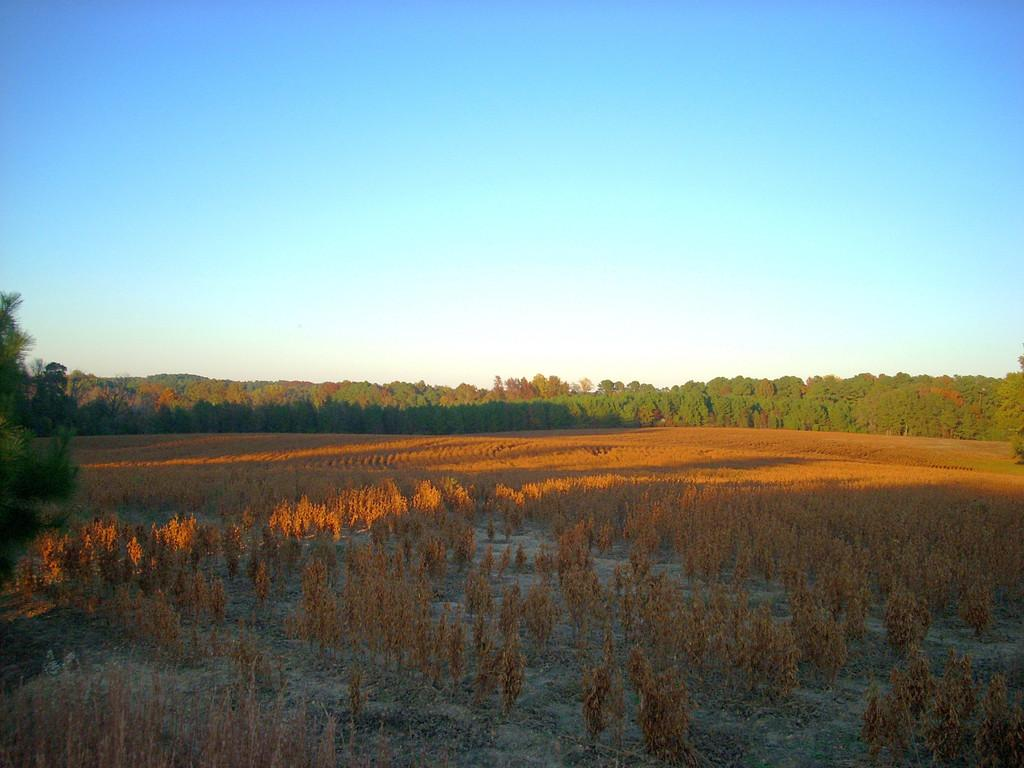What can be seen in the background of the image? There are trees in the background of the image. What color is the sky in the image? The sky is blue in color. What type of acoustics can be heard in the image? There is no sound or acoustics present in the image, as it is a still image. Who is the writer of the image? There is no writer associated with the image, as it is a visual representation and not a written work. 